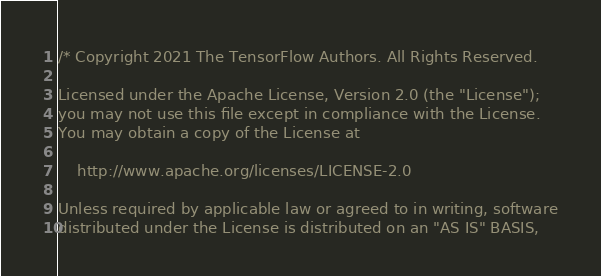<code> <loc_0><loc_0><loc_500><loc_500><_C++_>/* Copyright 2021 The TensorFlow Authors. All Rights Reserved.

Licensed under the Apache License, Version 2.0 (the "License");
you may not use this file except in compliance with the License.
You may obtain a copy of the License at

    http://www.apache.org/licenses/LICENSE-2.0

Unless required by applicable law or agreed to in writing, software
distributed under the License is distributed on an "AS IS" BASIS,</code> 